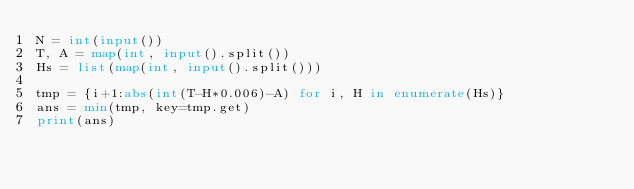<code> <loc_0><loc_0><loc_500><loc_500><_Python_>N = int(input())
T, A = map(int, input().split())
Hs = list(map(int, input().split()))

tmp = {i+1:abs(int(T-H*0.006)-A) for i, H in enumerate(Hs)}
ans = min(tmp, key=tmp.get)
print(ans)
</code> 